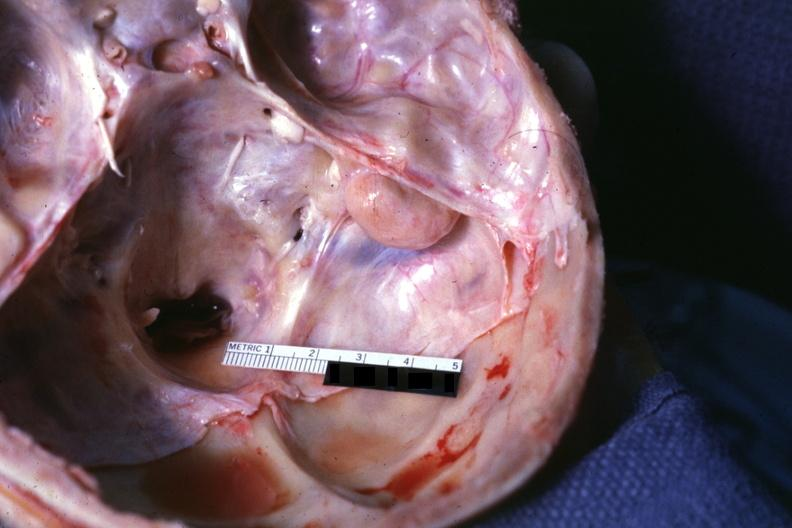does side show opened base of skull with brain removed?
Answer the question using a single word or phrase. No 